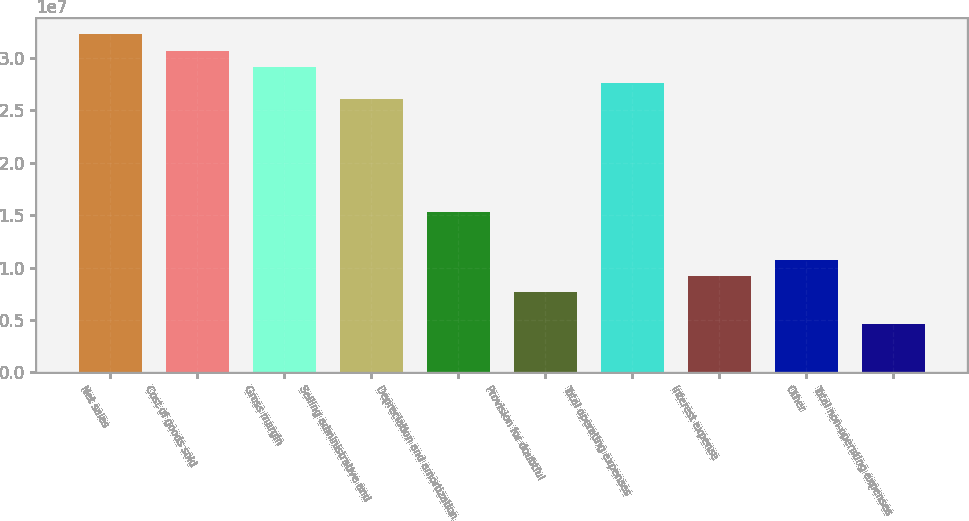<chart> <loc_0><loc_0><loc_500><loc_500><bar_chart><fcel>Net sales<fcel>Cost of goods sold<fcel>Gross margin<fcel>Selling administrative and<fcel>Depreciation and amortization<fcel>Provision for doubtful<fcel>Total operating expenses<fcel>Interest expense<fcel>Other<fcel>Total non-operating expenses<nl><fcel>3.22134e+07<fcel>3.06794e+07<fcel>2.91455e+07<fcel>2.60775e+07<fcel>1.53397e+07<fcel>7.66986e+06<fcel>2.76115e+07<fcel>9.20383e+06<fcel>1.07378e+07<fcel>4.60192e+06<nl></chart> 